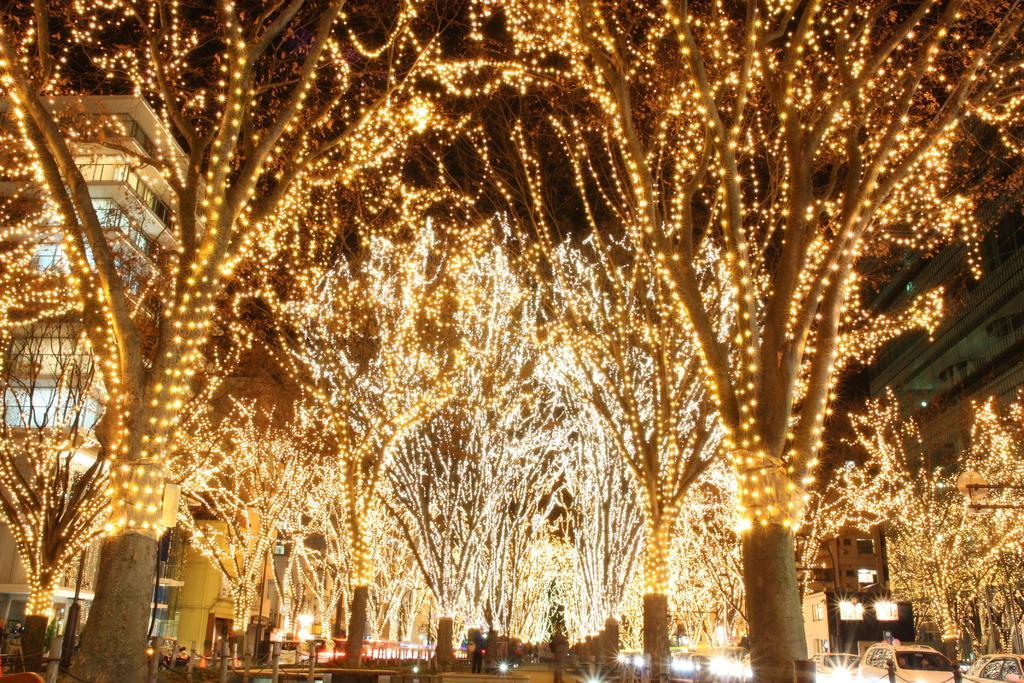In one or two sentences, can you explain what this image depicts? In this image, there are some trees, there are some lights on the trees, at the left side there is a building. 